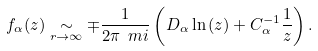<formula> <loc_0><loc_0><loc_500><loc_500>f _ { \alpha } ( z ) \underset { r \rightarrow \infty } { \sim } \mp \frac { 1 } { 2 \pi \ m i } \left ( D _ { \alpha } \ln { ( z ) } + C _ { \alpha } ^ { - 1 } \frac { 1 } { z } \right ) .</formula> 